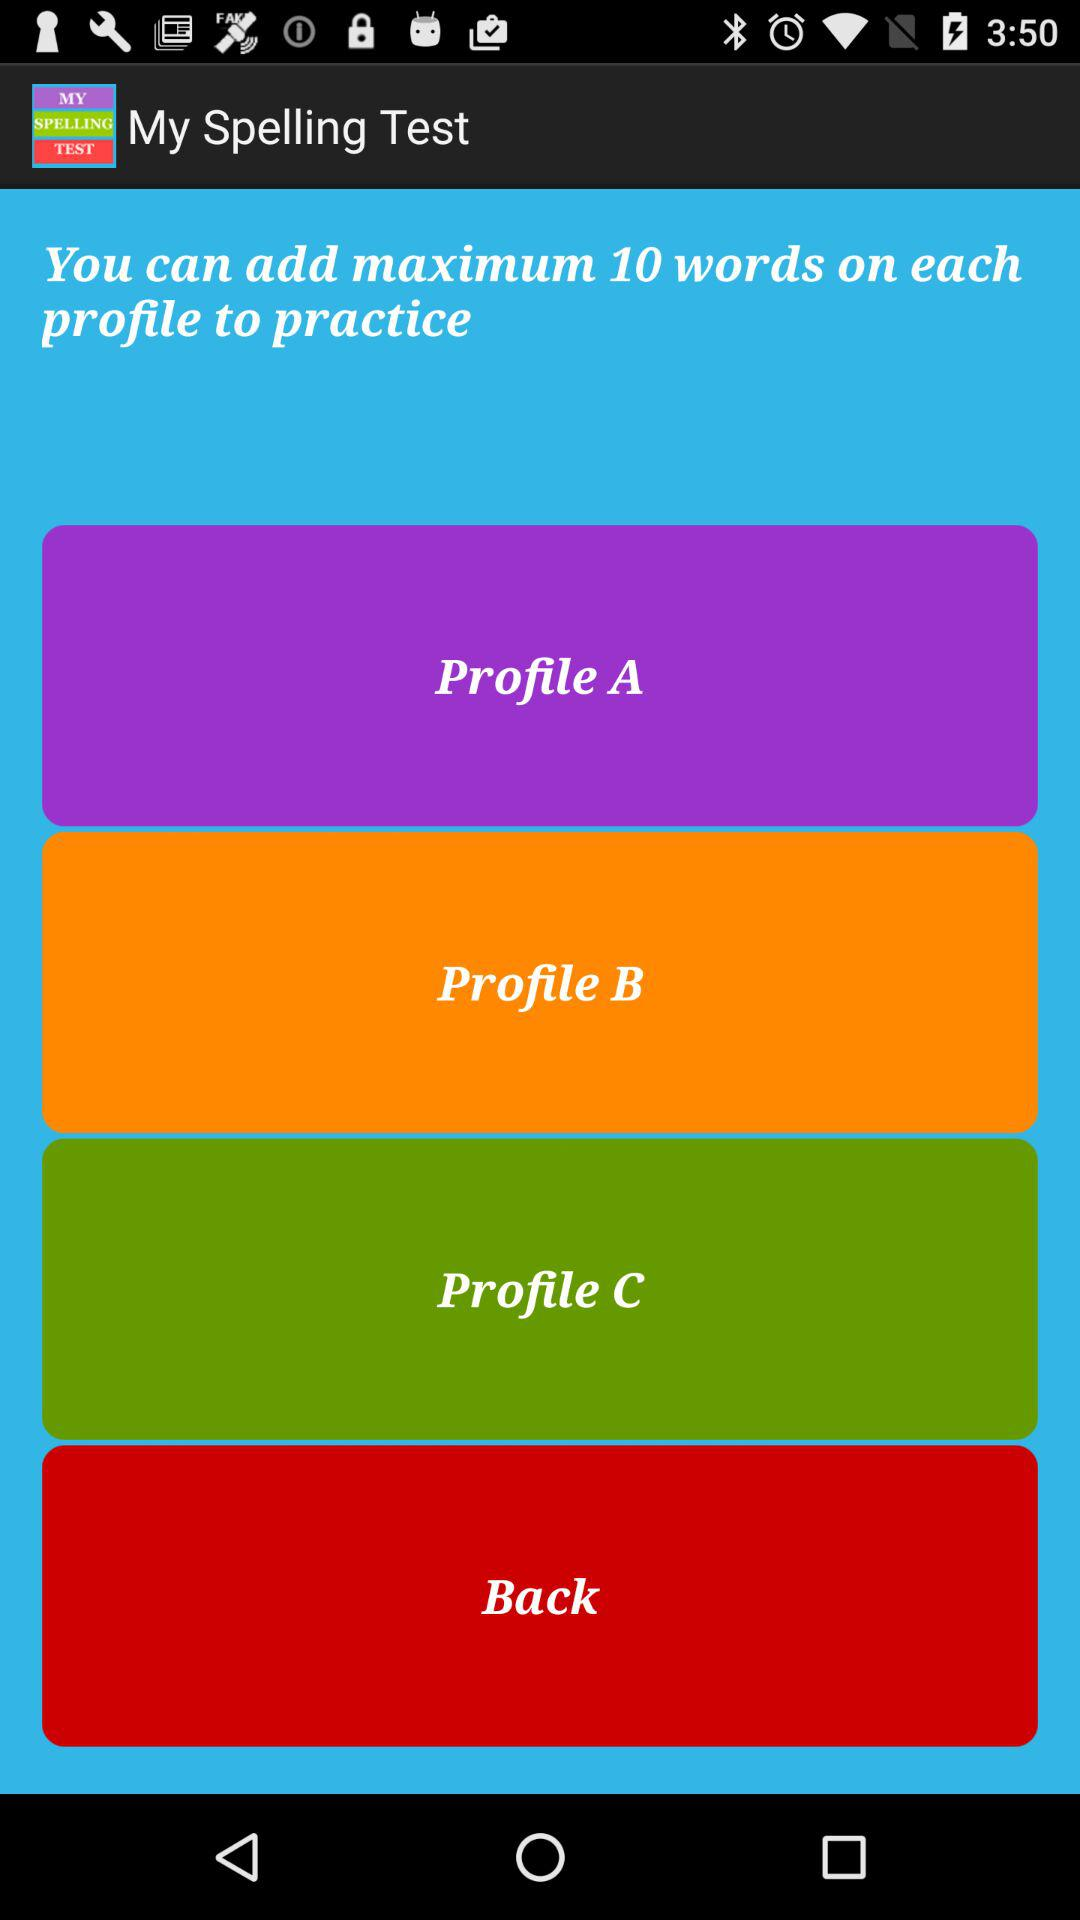How many profiles are there?
Answer the question using a single word or phrase. 3 